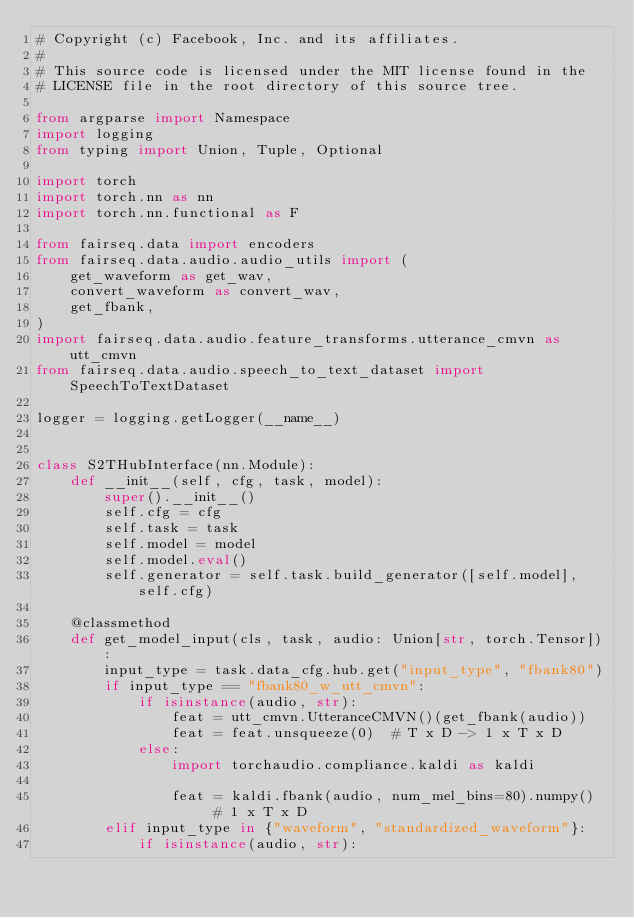Convert code to text. <code><loc_0><loc_0><loc_500><loc_500><_Python_># Copyright (c) Facebook, Inc. and its affiliates.
#
# This source code is licensed under the MIT license found in the
# LICENSE file in the root directory of this source tree.

from argparse import Namespace
import logging
from typing import Union, Tuple, Optional

import torch
import torch.nn as nn
import torch.nn.functional as F

from fairseq.data import encoders
from fairseq.data.audio.audio_utils import (
    get_waveform as get_wav,
    convert_waveform as convert_wav,
    get_fbank,
)
import fairseq.data.audio.feature_transforms.utterance_cmvn as utt_cmvn
from fairseq.data.audio.speech_to_text_dataset import SpeechToTextDataset

logger = logging.getLogger(__name__)


class S2THubInterface(nn.Module):
    def __init__(self, cfg, task, model):
        super().__init__()
        self.cfg = cfg
        self.task = task
        self.model = model
        self.model.eval()
        self.generator = self.task.build_generator([self.model], self.cfg)

    @classmethod
    def get_model_input(cls, task, audio: Union[str, torch.Tensor]):
        input_type = task.data_cfg.hub.get("input_type", "fbank80")
        if input_type == "fbank80_w_utt_cmvn":
            if isinstance(audio, str):
                feat = utt_cmvn.UtteranceCMVN()(get_fbank(audio))
                feat = feat.unsqueeze(0)  # T x D -> 1 x T x D
            else:
                import torchaudio.compliance.kaldi as kaldi

                feat = kaldi.fbank(audio, num_mel_bins=80).numpy()  # 1 x T x D
        elif input_type in {"waveform", "standardized_waveform"}:
            if isinstance(audio, str):</code> 